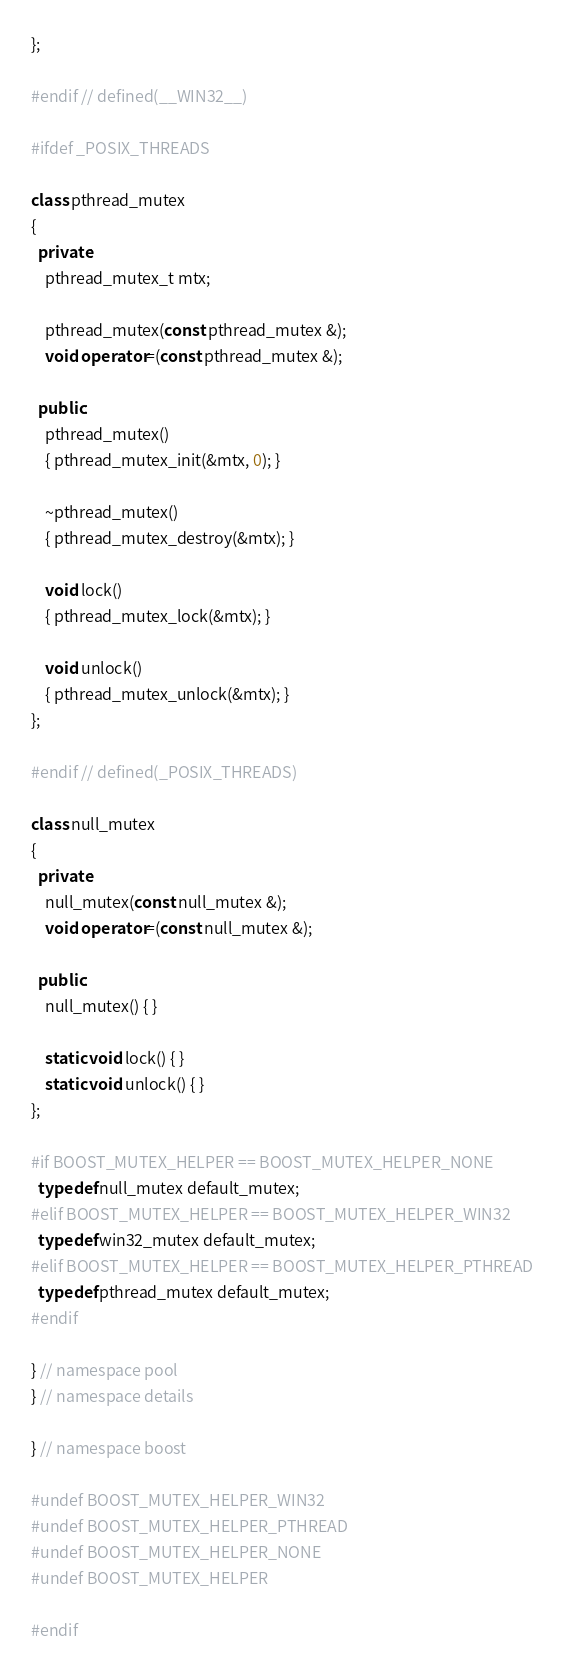<code> <loc_0><loc_0><loc_500><loc_500><_C++_>};

#endif // defined(__WIN32__)

#ifdef _POSIX_THREADS

class pthread_mutex
{
  private:
    pthread_mutex_t mtx;

    pthread_mutex(const pthread_mutex &);
    void operator=(const pthread_mutex &);

  public:
    pthread_mutex()
    { pthread_mutex_init(&mtx, 0); }

    ~pthread_mutex()
    { pthread_mutex_destroy(&mtx); }

    void lock()
    { pthread_mutex_lock(&mtx); }

    void unlock()
    { pthread_mutex_unlock(&mtx); }
};

#endif // defined(_POSIX_THREADS)

class null_mutex
{
  private:
    null_mutex(const null_mutex &);
    void operator=(const null_mutex &);

  public:
    null_mutex() { }

    static void lock() { }
    static void unlock() { }
};

#if BOOST_MUTEX_HELPER == BOOST_MUTEX_HELPER_NONE
  typedef null_mutex default_mutex;
#elif BOOST_MUTEX_HELPER == BOOST_MUTEX_HELPER_WIN32
  typedef win32_mutex default_mutex;
#elif BOOST_MUTEX_HELPER == BOOST_MUTEX_HELPER_PTHREAD
  typedef pthread_mutex default_mutex;
#endif

} // namespace pool
} // namespace details

} // namespace boost

#undef BOOST_MUTEX_HELPER_WIN32
#undef BOOST_MUTEX_HELPER_PTHREAD
#undef BOOST_MUTEX_HELPER_NONE
#undef BOOST_MUTEX_HELPER

#endif
</code> 